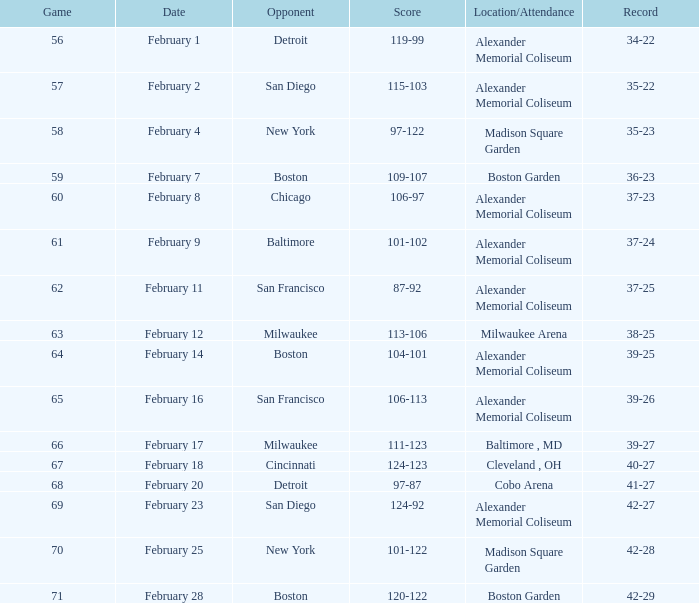What is the Game # that scored 87-92? 62.0. 